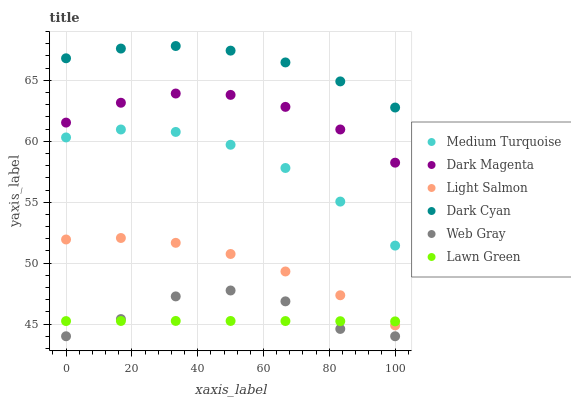Does Lawn Green have the minimum area under the curve?
Answer yes or no. Yes. Does Dark Cyan have the maximum area under the curve?
Answer yes or no. Yes. Does Light Salmon have the minimum area under the curve?
Answer yes or no. No. Does Light Salmon have the maximum area under the curve?
Answer yes or no. No. Is Lawn Green the smoothest?
Answer yes or no. Yes. Is Web Gray the roughest?
Answer yes or no. Yes. Is Light Salmon the smoothest?
Answer yes or no. No. Is Light Salmon the roughest?
Answer yes or no. No. Does Web Gray have the lowest value?
Answer yes or no. Yes. Does Light Salmon have the lowest value?
Answer yes or no. No. Does Dark Cyan have the highest value?
Answer yes or no. Yes. Does Light Salmon have the highest value?
Answer yes or no. No. Is Medium Turquoise less than Dark Magenta?
Answer yes or no. Yes. Is Medium Turquoise greater than Light Salmon?
Answer yes or no. Yes. Does Web Gray intersect Lawn Green?
Answer yes or no. Yes. Is Web Gray less than Lawn Green?
Answer yes or no. No. Is Web Gray greater than Lawn Green?
Answer yes or no. No. Does Medium Turquoise intersect Dark Magenta?
Answer yes or no. No. 